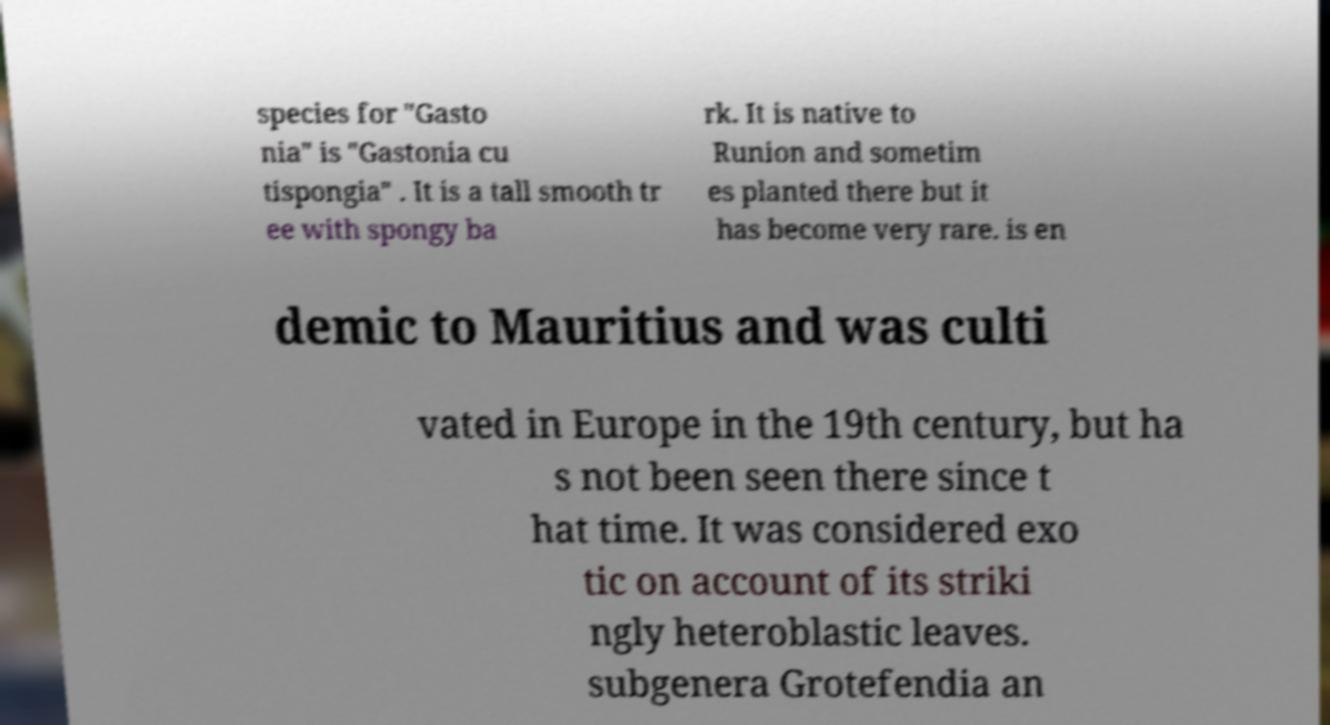For documentation purposes, I need the text within this image transcribed. Could you provide that? species for "Gasto nia" is "Gastonia cu tispongia" . It is a tall smooth tr ee with spongy ba rk. It is native to Runion and sometim es planted there but it has become very rare. is en demic to Mauritius and was culti vated in Europe in the 19th century, but ha s not been seen there since t hat time. It was considered exo tic on account of its striki ngly heteroblastic leaves. subgenera Grotefendia an 